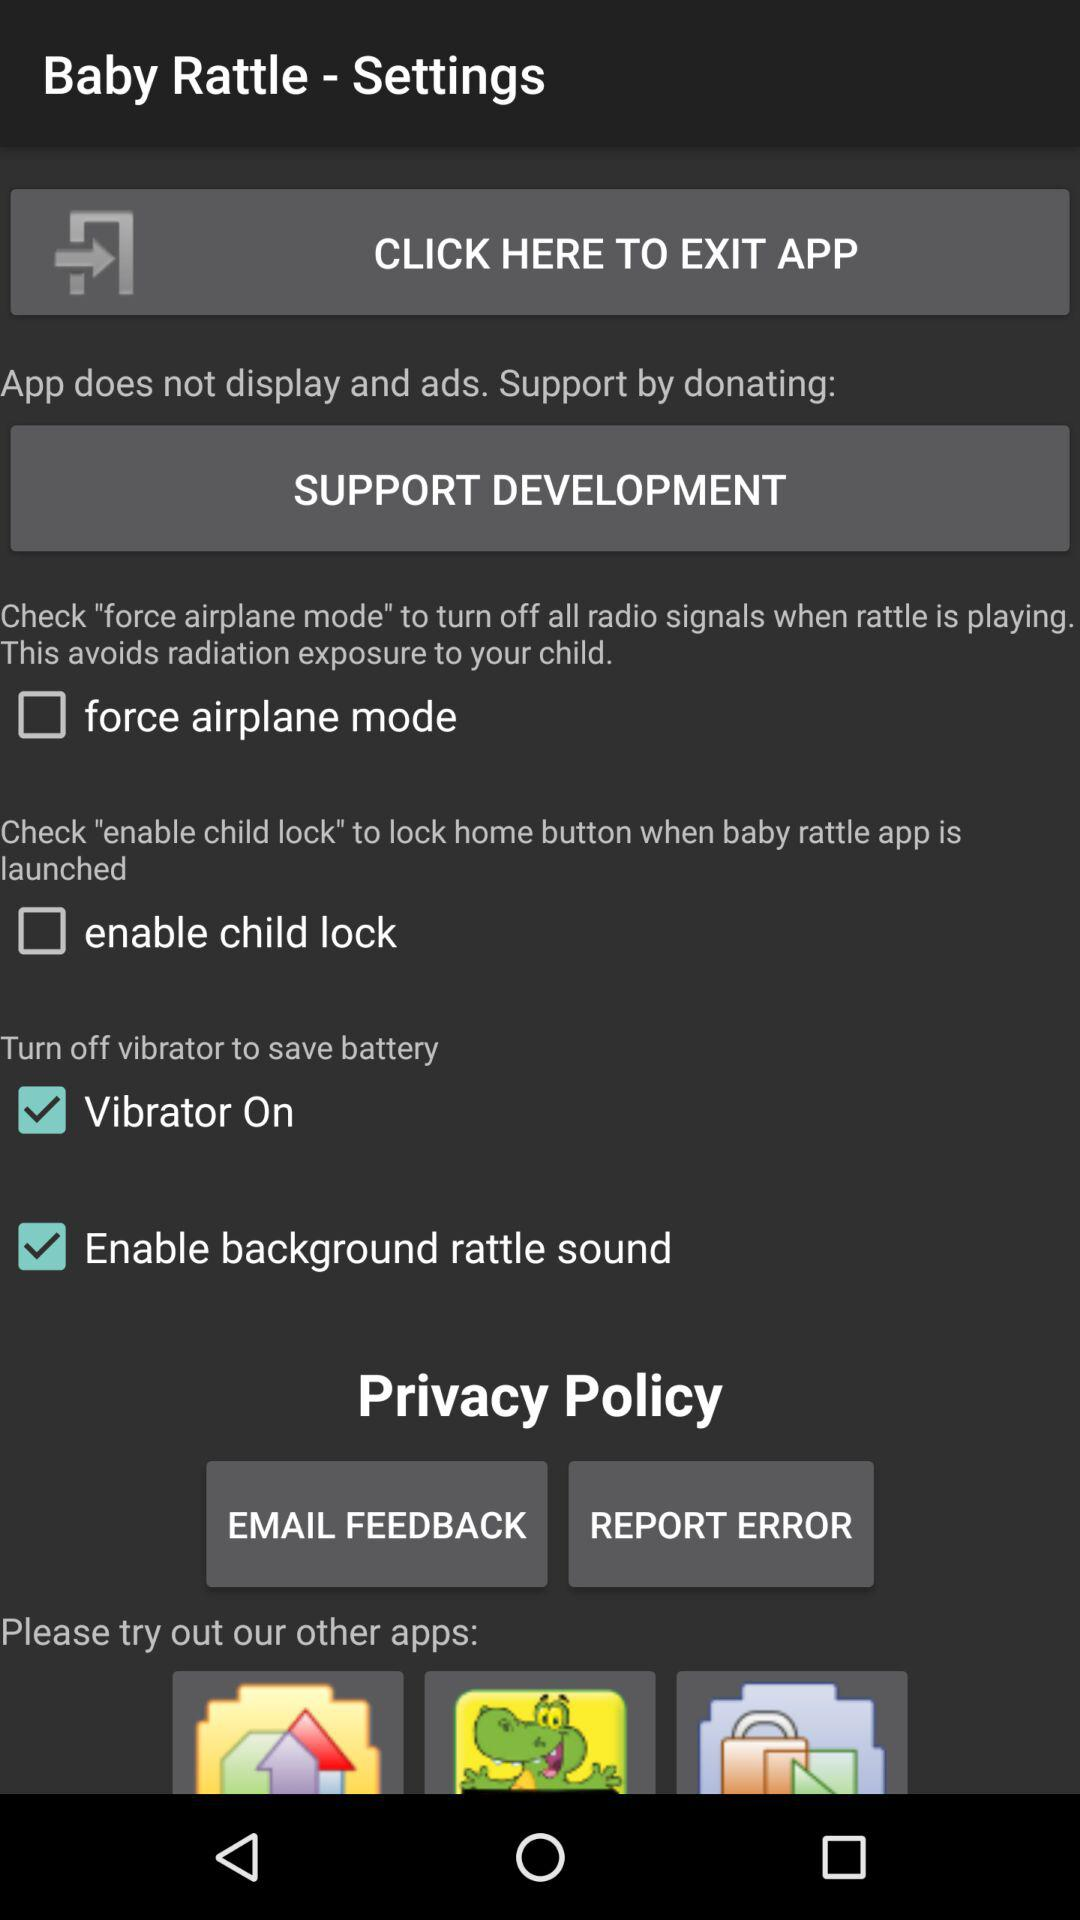What is the status of "force airplane mode"? The status of "force airplane mode" is "off". 